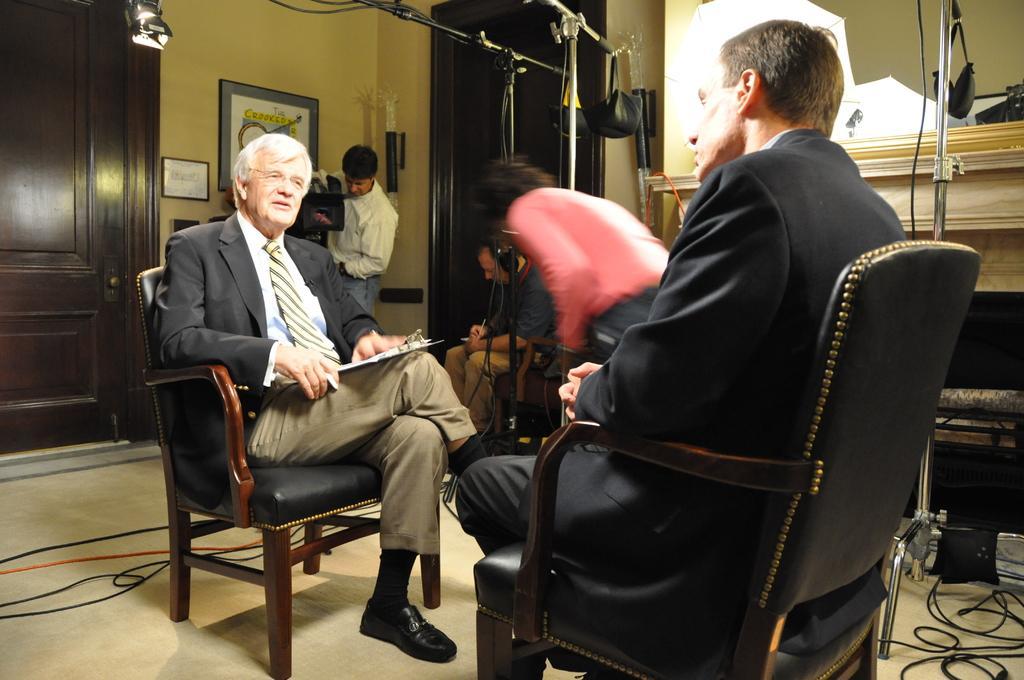Describe this image in one or two sentences. In this image i can see two man sitting on a chair at the back ground i can see three persons, the person standing at back holding a camera, the frame attached to a wall and a door. 